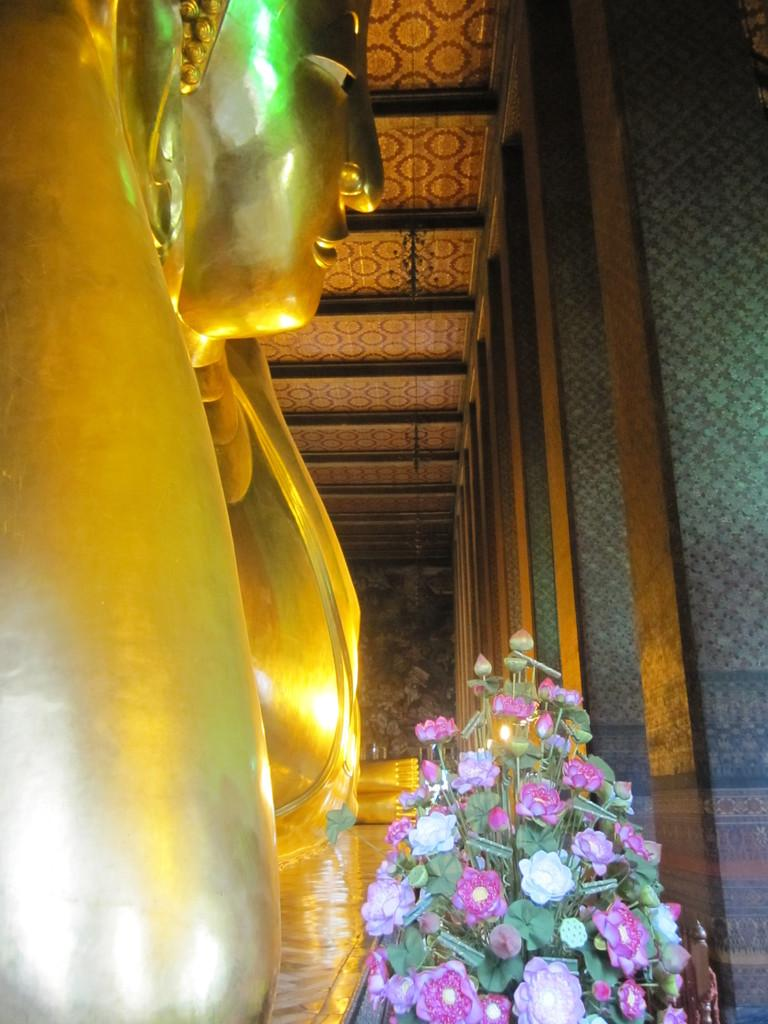What is located on the left side of the image? There is a statue on the left side of the image. What can be seen on the right side of the image? There is a flower bouquet on the right side of the image. What type of architectural feature is visible in the image? There are glass doors in the background of the image. What is present on the ceiling in the background of the image? There are objects on the ceiling in the background of the image. What type of copper material is present in the image? There is no copper material present in the image. What emotion is depicted by the statue in the image? The emotion of the statue cannot be determined from the image alone, as it is a static object. 